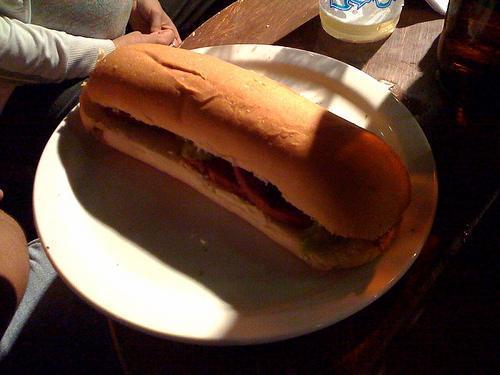How many sandwiches are there?
Give a very brief answer. 1. How many people are there?
Give a very brief answer. 2. How many people are seen?
Give a very brief answer. 1. How many people are in the photo?
Give a very brief answer. 2. How many horses are in the photo?
Give a very brief answer. 0. 